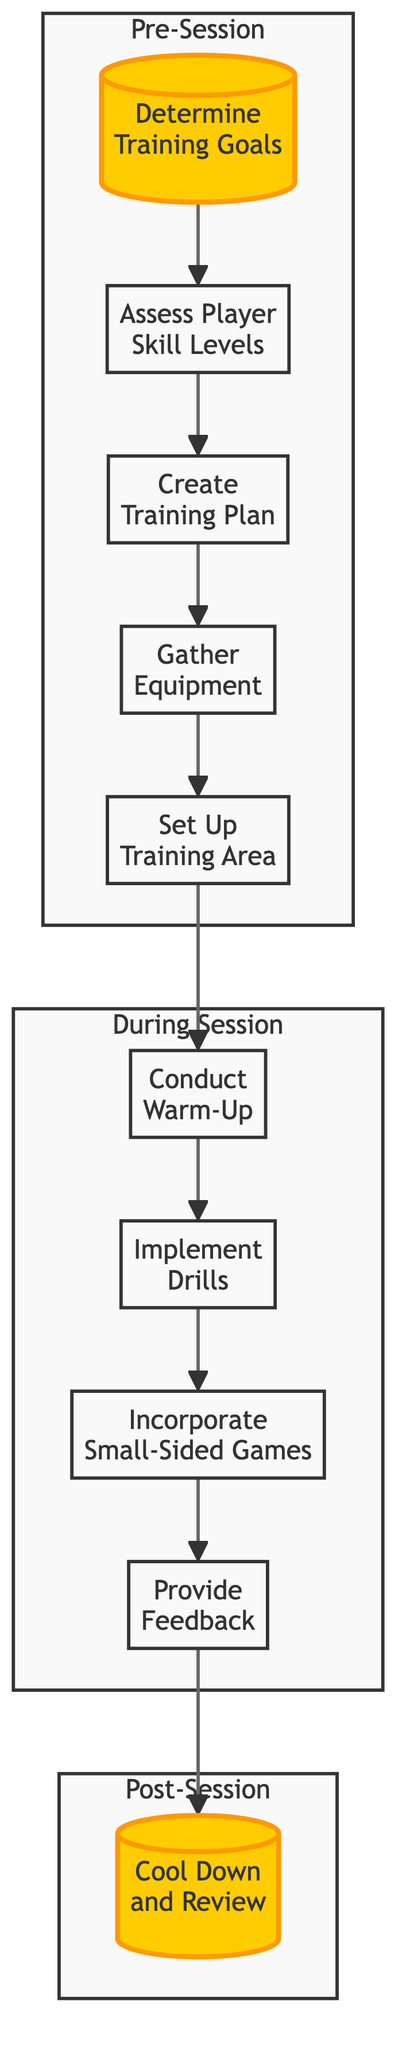What is the first step in the training session planning? The first step in the diagram is labeled as "Determine Training Goals." It is represented as the starting point in the flowchart, indicating where the planning process begins.
Answer: Determine Training Goals How many main steps are there in the training session planning? By counting the elements represented in the diagram, there are a total of ten main steps that outline the entire training session planning process.
Answer: 10 What is the last action taken in the training session? The last action in the flowchart is "Cool Down and Review," which signifies that this is the concluding step of the training session.
Answer: Cool Down and Review Which step comes after "Gather Equipment"? Following "Gather Equipment," the next step outlined in the flowchart is "Set Up Training Area." This shows a clear progression in the planning process.
Answer: Set Up Training Area What is the purpose of the "Provide Feedback" step? "Provide Feedback" is positioned before the last step and aims to enhance player development by giving constructive criticism about their performance during drills. This indicates the role of feedback in training.
Answer: Enhance player development Can you explain what happens during the "During Session" block? The "During Session" block encompasses actions from "Conduct Warm-Up" through to "Provide Feedback." This shows all the activities that occur while the training session is actually happening.
Answer: Warm-up, drills, small-sided games, feedback How does "Assess Player Skill Levels" connect to "Create Training Plan"? "Assess Player Skill Levels" directly leads into "Create Training Plan," indicating that evaluating players' skills is crucial for tailoring an effective training session plan. This dependency highlights the relationship between understanding players' abilities and planning the training sessions accordingly.
Answer: They're directly connected What is the main focus of the "Incorporate Small-Sided Games" step? The primary focus of "Incorporate Small-Sided Games" is to promote teamwork and apply the skills learned during drills in a competitive yet fun environment. This illustrates the importance of practical application in learning.
Answer: Promote teamwork Which node represents a preparatory action before the actual drills? The node "Conduct Warm-Up" represents a preparatory action that takes place before implementing the actual drills in the training session. This step is essential for physically preparing the players.
Answer: Conduct Warm-Up 